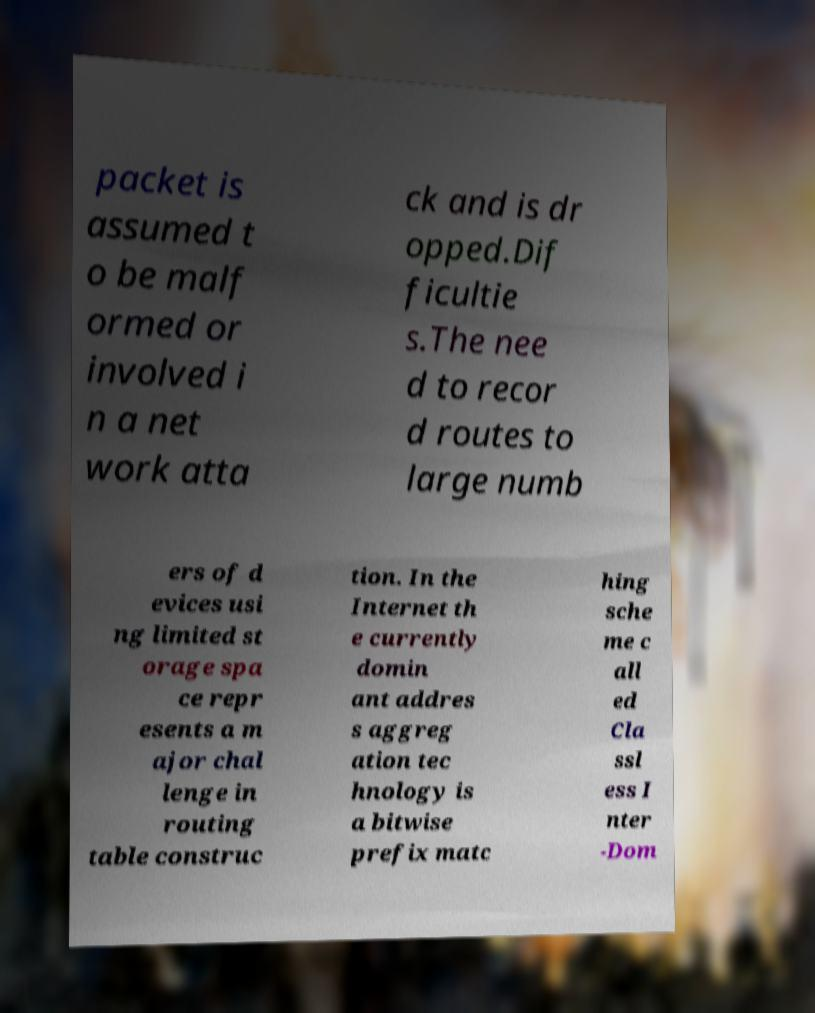Please identify and transcribe the text found in this image. packet is assumed t o be malf ormed or involved i n a net work atta ck and is dr opped.Dif ficultie s.The nee d to recor d routes to large numb ers of d evices usi ng limited st orage spa ce repr esents a m ajor chal lenge in routing table construc tion. In the Internet th e currently domin ant addres s aggreg ation tec hnology is a bitwise prefix matc hing sche me c all ed Cla ssl ess I nter -Dom 